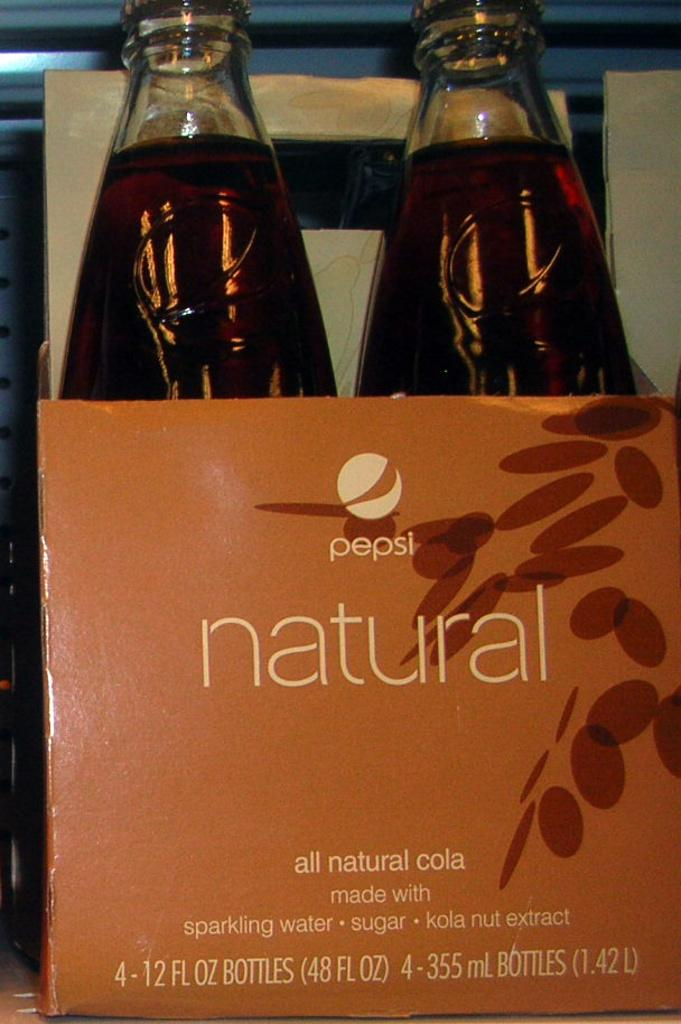Provide a one-sentence caption for the provided image. A 2 pack of pepsi natural cola bottles. 